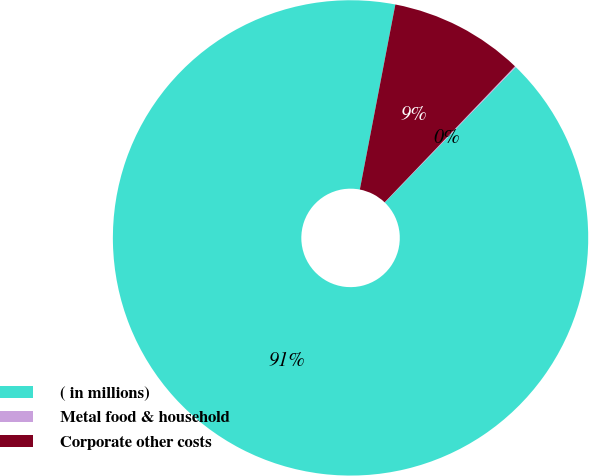Convert chart to OTSL. <chart><loc_0><loc_0><loc_500><loc_500><pie_chart><fcel>( in millions)<fcel>Metal food & household<fcel>Corporate other costs<nl><fcel>90.78%<fcel>0.07%<fcel>9.14%<nl></chart> 